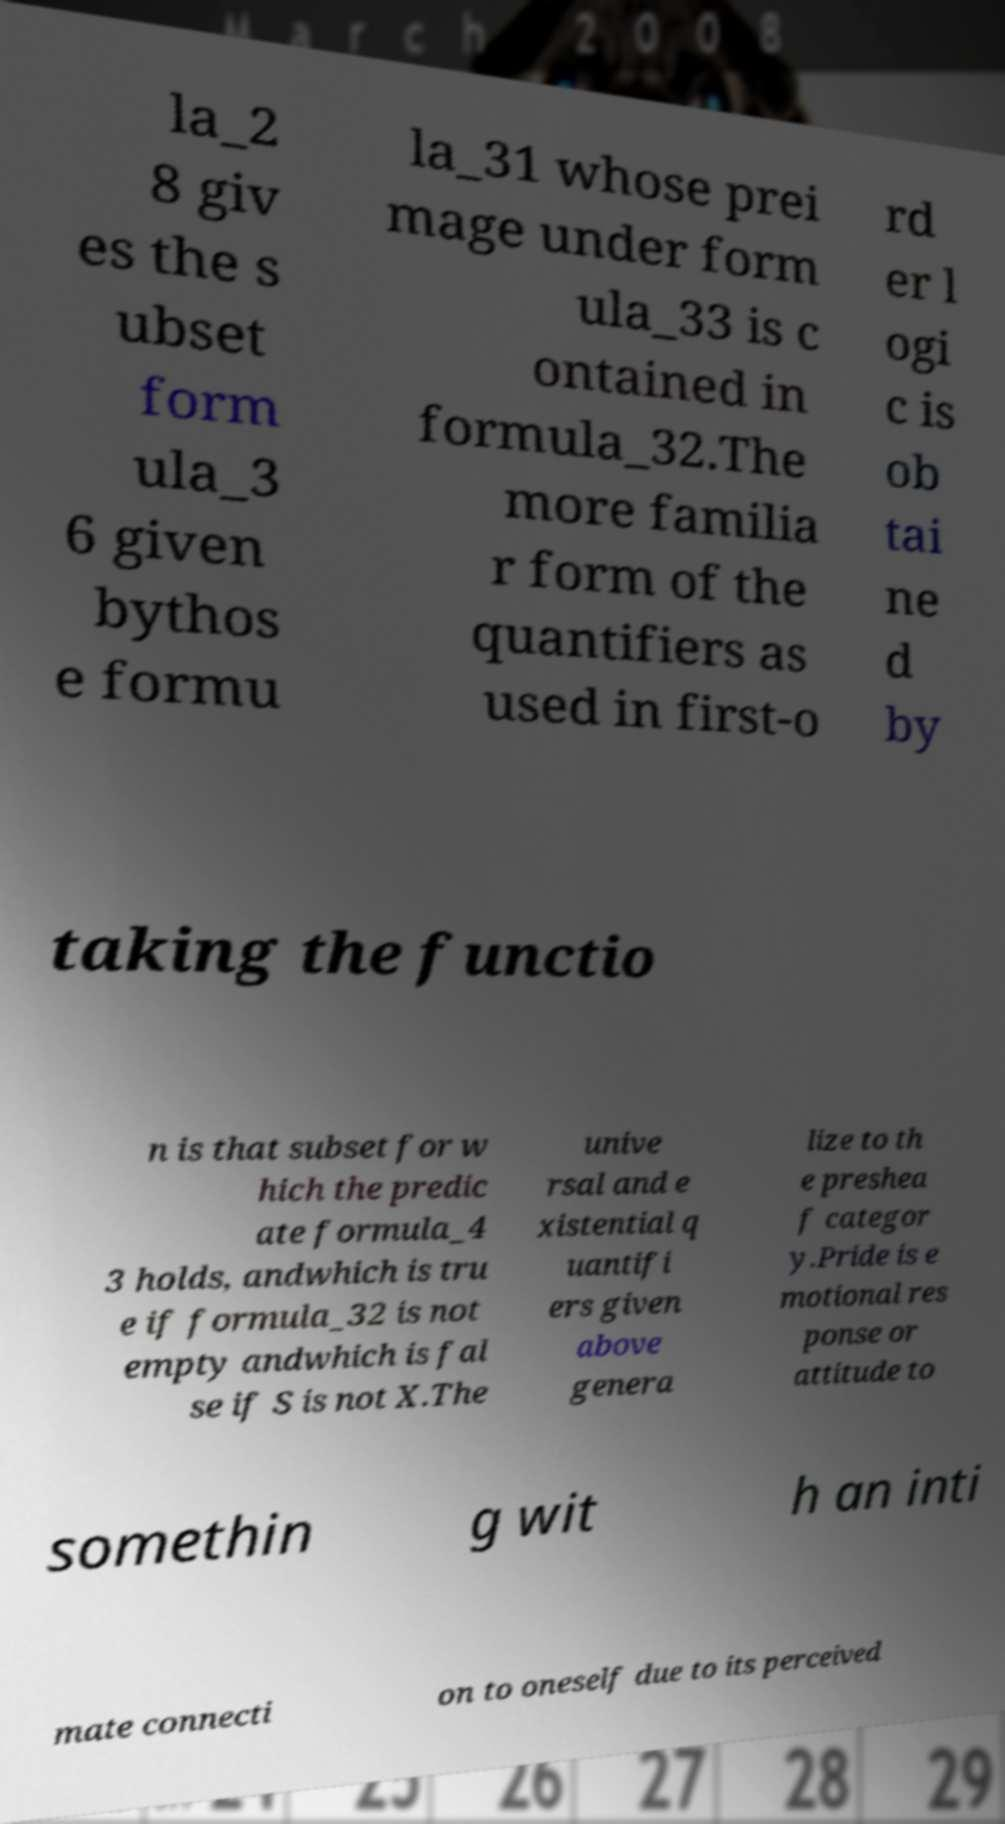Could you assist in decoding the text presented in this image and type it out clearly? la_2 8 giv es the s ubset form ula_3 6 given bythos e formu la_31 whose prei mage under form ula_33 is c ontained in formula_32.The more familia r form of the quantifiers as used in first-o rd er l ogi c is ob tai ne d by taking the functio n is that subset for w hich the predic ate formula_4 3 holds, andwhich is tru e if formula_32 is not empty andwhich is fal se if S is not X.The unive rsal and e xistential q uantifi ers given above genera lize to th e preshea f categor y.Pride is e motional res ponse or attitude to somethin g wit h an inti mate connecti on to oneself due to its perceived 